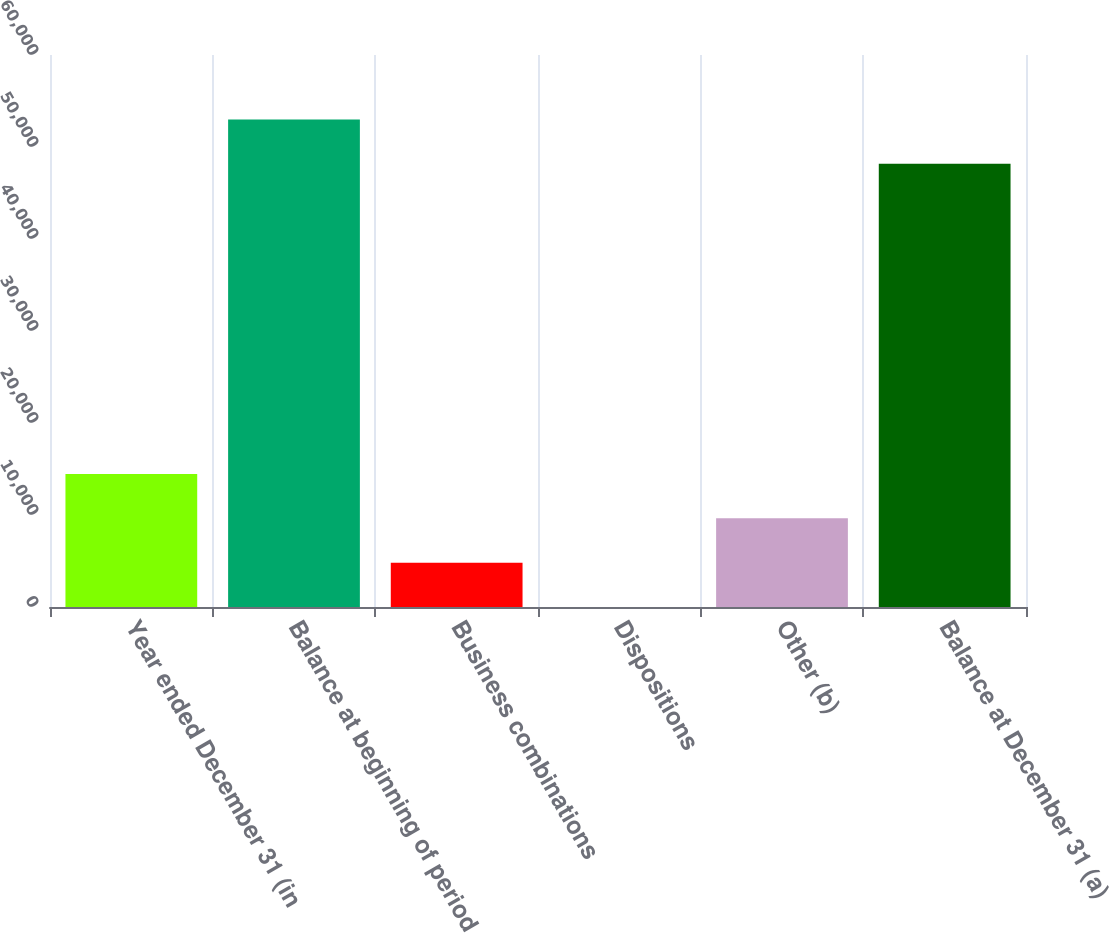Convert chart. <chart><loc_0><loc_0><loc_500><loc_500><bar_chart><fcel>Year ended December 31 (in<fcel>Balance at beginning of period<fcel>Business combinations<fcel>Dispositions<fcel>Other (b)<fcel>Balance at December 31 (a)<nl><fcel>14459.2<fcel>52993.4<fcel>4822.4<fcel>4<fcel>9640.8<fcel>48175<nl></chart> 